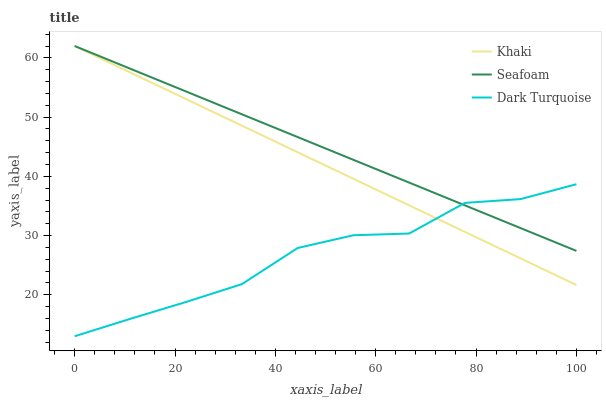Does Dark Turquoise have the minimum area under the curve?
Answer yes or no. Yes. Does Seafoam have the maximum area under the curve?
Answer yes or no. Yes. Does Khaki have the minimum area under the curve?
Answer yes or no. No. Does Khaki have the maximum area under the curve?
Answer yes or no. No. Is Khaki the smoothest?
Answer yes or no. Yes. Is Dark Turquoise the roughest?
Answer yes or no. Yes. Is Seafoam the smoothest?
Answer yes or no. No. Is Seafoam the roughest?
Answer yes or no. No. Does Dark Turquoise have the lowest value?
Answer yes or no. Yes. Does Khaki have the lowest value?
Answer yes or no. No. Does Seafoam have the highest value?
Answer yes or no. Yes. Does Seafoam intersect Khaki?
Answer yes or no. Yes. Is Seafoam less than Khaki?
Answer yes or no. No. Is Seafoam greater than Khaki?
Answer yes or no. No. 